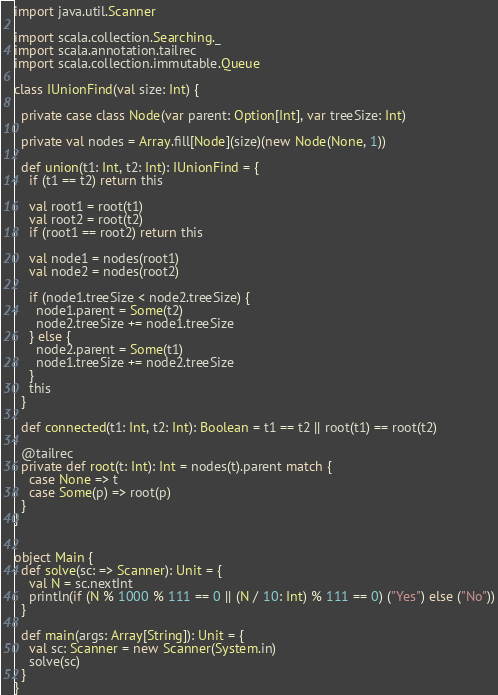Convert code to text. <code><loc_0><loc_0><loc_500><loc_500><_Scala_>import java.util.Scanner

import scala.collection.Searching._
import scala.annotation.tailrec
import scala.collection.immutable.Queue

class IUnionFind(val size: Int) {

  private case class Node(var parent: Option[Int], var treeSize: Int)

  private val nodes = Array.fill[Node](size)(new Node(None, 1))

  def union(t1: Int, t2: Int): IUnionFind = {
    if (t1 == t2) return this

    val root1 = root(t1)
    val root2 = root(t2)
    if (root1 == root2) return this

    val node1 = nodes(root1)
    val node2 = nodes(root2)

    if (node1.treeSize < node2.treeSize) {
      node1.parent = Some(t2)
      node2.treeSize += node1.treeSize
    } else {
      node2.parent = Some(t1)
      node1.treeSize += node2.treeSize
    }
    this
  }

  def connected(t1: Int, t2: Int): Boolean = t1 == t2 || root(t1) == root(t2)

  @tailrec
  private def root(t: Int): Int = nodes(t).parent match {
    case None => t
    case Some(p) => root(p)
  }
}


object Main {
  def solve(sc: => Scanner): Unit = {
    val N = sc.nextInt
    println(if (N % 1000 % 111 == 0 || (N / 10: Int) % 111 == 0) ("Yes") else ("No"))
  }

  def main(args: Array[String]): Unit = {
    val sc: Scanner = new Scanner(System.in)
    solve(sc)
  }
}</code> 